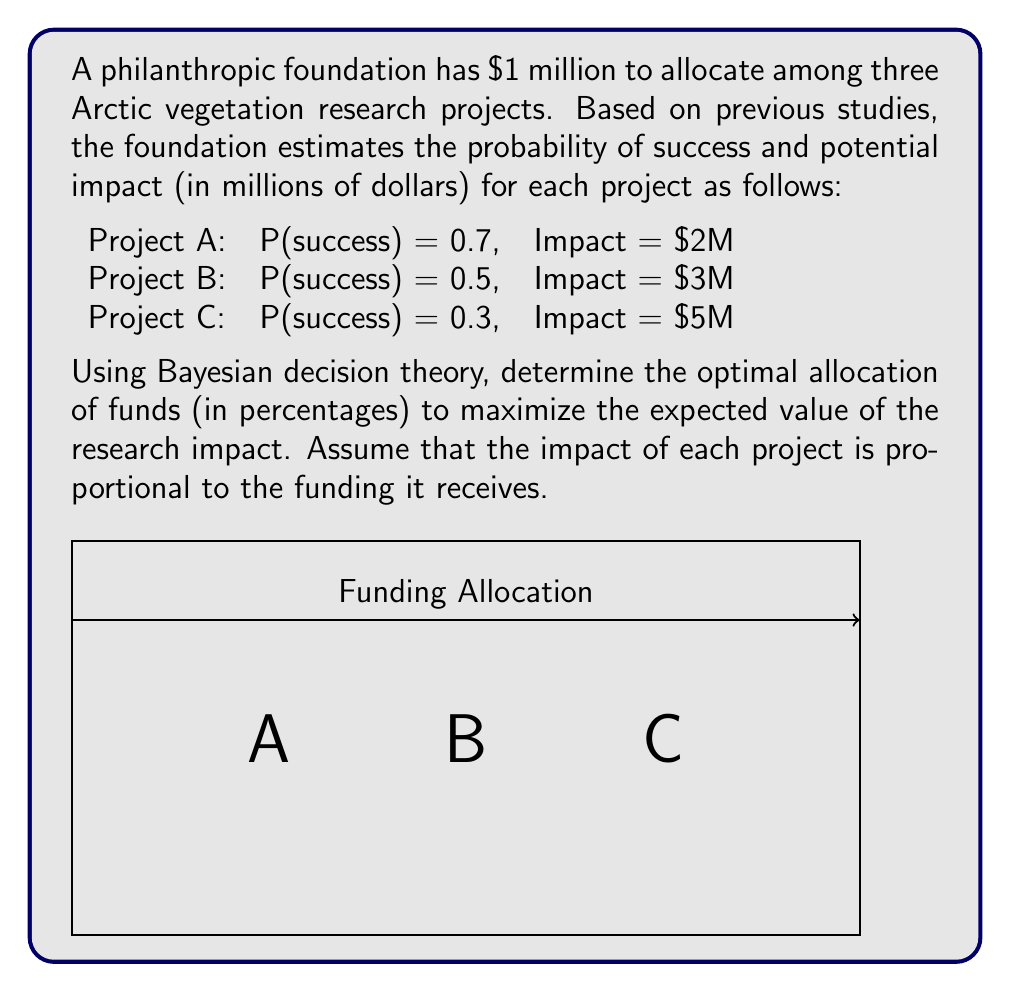Could you help me with this problem? To solve this problem using Bayesian decision theory, we need to calculate the expected value for each project and then optimize the allocation of funds to maximize the overall expected value. Let's break it down step-by-step:

1) First, let's define variables for the allocation percentages:
   Let $a$, $b$, and $c$ be the percentages allocated to Projects A, B, and C respectively.

2) The expected value (EV) for each project is:
   $$EV_A = 0.7 \times 2a = 1.4a$$
   $$EV_B = 0.5 \times 3b = 1.5b$$
   $$EV_C = 0.3 \times 5c = 1.5c$$

3) The total expected value is the sum of these:
   $$EV_{total} = 1.4a + 1.5b + 1.5c$$

4) We need to maximize this value subject to the constraints:
   $$a + b + c = 100\%$$
   $$a, b, c \geq 0$$

5) Given that the coefficients for $b$ and $c$ are equal and higher than $a$, the optimal solution is to allocate all funds to either B or C, or split between them.

6) Since B and C have the same expected value per dollar (1.5), we can choose either. Let's choose C for its higher potential impact.

7) Therefore, the optimal allocation is:
   $$a = 0\%, b = 0\%, c = 100\%$$

This allocation maximizes the expected value of the research impact given the probabilities and potential impacts of each project.
Answer: Project A: 0%, Project B: 0%, Project C: 100% 